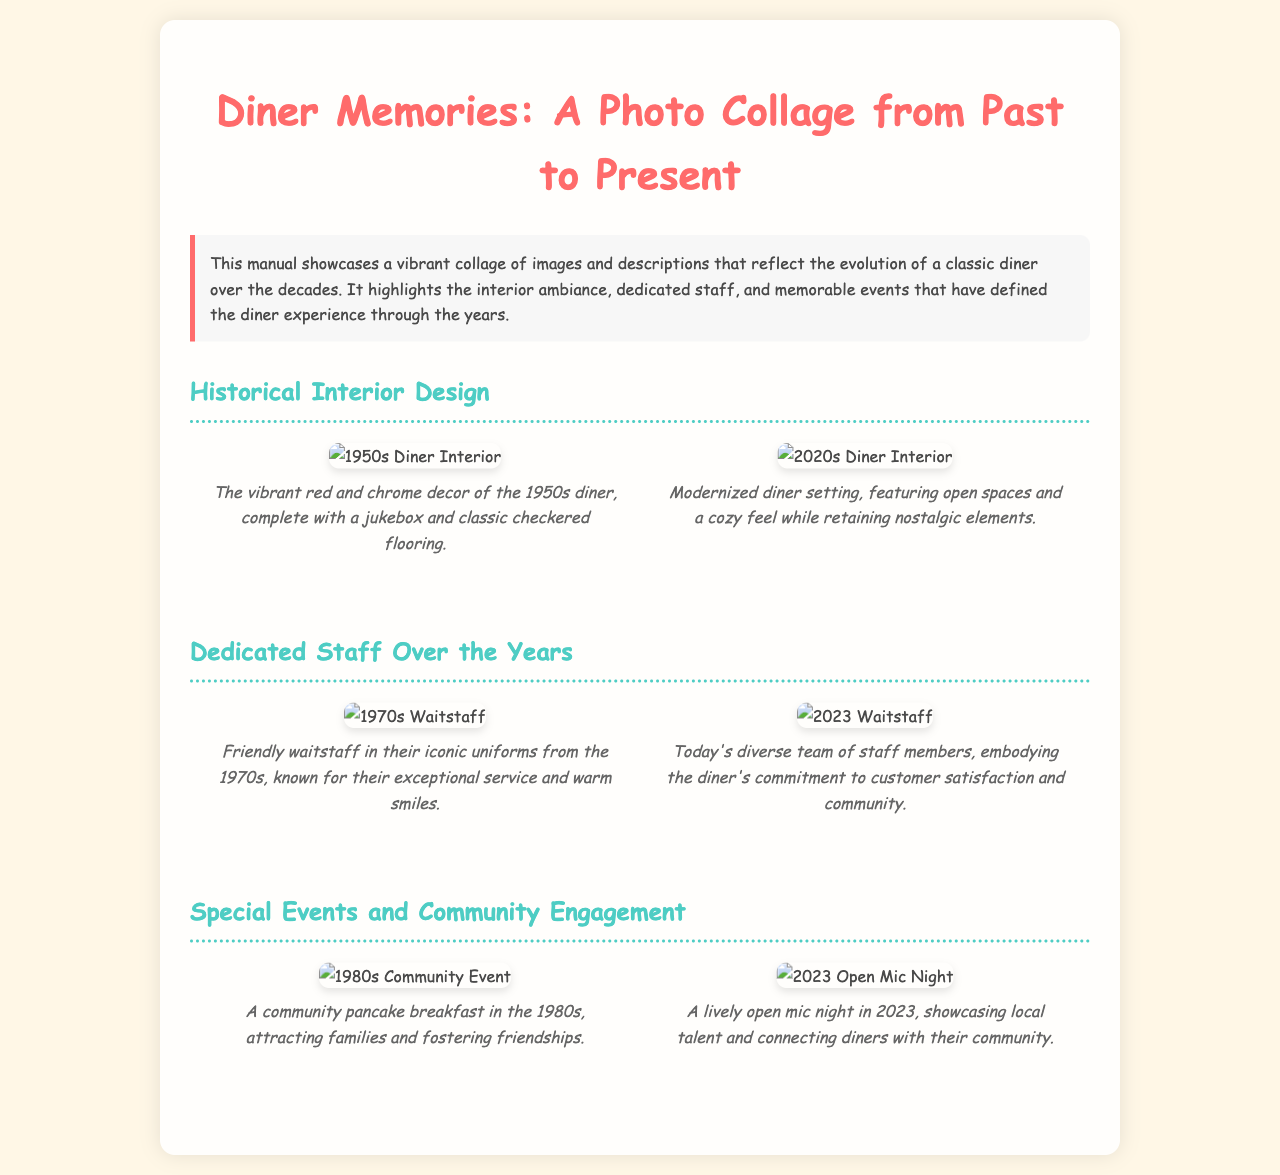what year is the oldest image of the diner interior from? The document mentions a photo of the diner interior from the 1950s.
Answer: 1950s how many images are in the section about dedicated staff? The dedicated staff section includes two images of staff members from different years.
Answer: 2 which decade featured the iconic waitstaff uniforms? The 1970s section highlights the waitstaff in their iconic uniforms.
Answer: 1970s what type of event is depicted in the 1980s image? The 1980s image showcases a community pancake breakfast as part of the diner's special events.
Answer: community pancake breakfast what color theme is associated with the 1950s diner interior? The caption for the 1950s interior describes vibrant red and chrome decor.
Answer: red and chrome which event in 2023 highlights local talent? The 2023 image features an open mic night showcasing local talent.
Answer: open mic night how does the 2020s interior differ from the 1950s interior? The 2020s interior is described as modernized with an open space while still retaining nostalgic elements.
Answer: modernized with open spaces who are highlighted in the section about dedicated staff? The section features friendly waitstaff from the 1970s and today's diverse team of staff members.
Answer: waitstaff from the 1970s and today's diverse team what visual feature is common to both interior images from the diner? Both images of the diner interior include nostalgic elements that reflect the diner's history.
Answer: nostalgic elements 